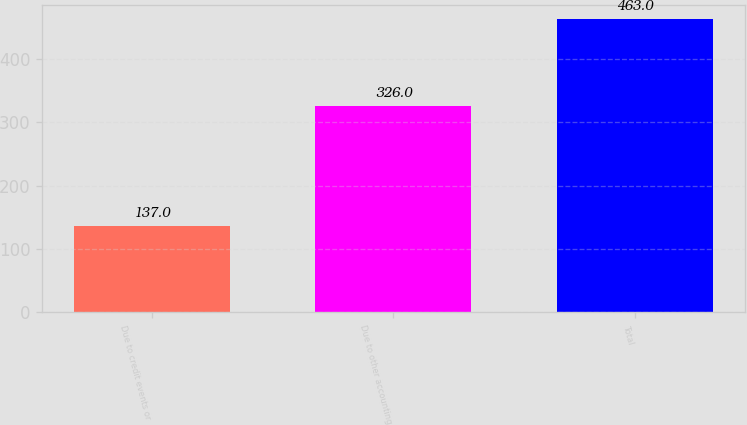Convert chart. <chart><loc_0><loc_0><loc_500><loc_500><bar_chart><fcel>Due to credit events or<fcel>Due to other accounting<fcel>Total<nl><fcel>137<fcel>326<fcel>463<nl></chart> 